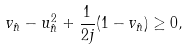Convert formula to latex. <formula><loc_0><loc_0><loc_500><loc_500>v _ { \hat { n } } - u _ { \hat { n } } ^ { 2 } + \frac { 1 } { 2 j } ( 1 - v _ { \hat { n } } ) \geq 0 ,</formula> 